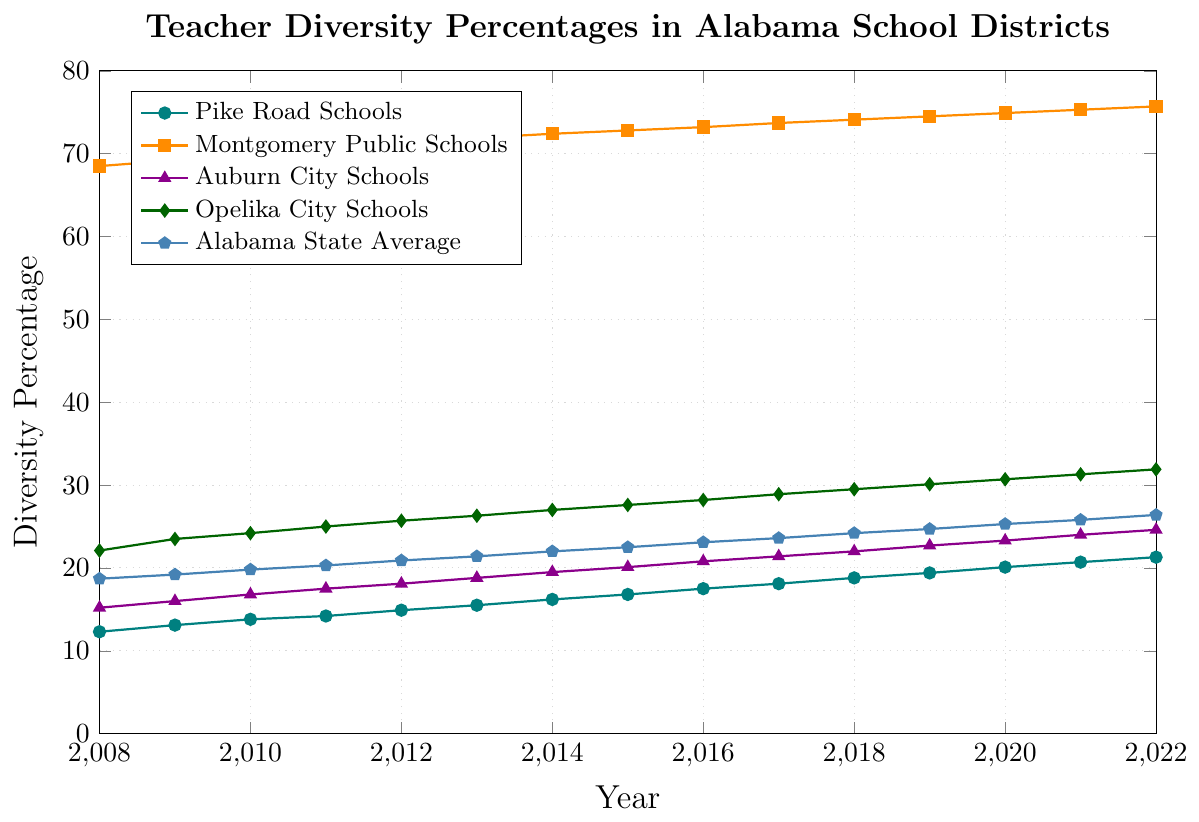What is the diversity percentage of teachers in Pike Road Schools in 2022? To find the diversity percentage for Pike Road Schools in 2022, locate the point corresponding to that year in the Pike Road Schools series (marked with circles) on the chart.
Answer: 21.3% What is the difference in teacher diversity between Montgomery Public Schools and Pike Road Schools in 2010? Subtract the diversity percentage of Pike Road Schools (13.8) from that of Montgomery Public Schools (70.1) for the year 2010.
Answer: 56.3% Which school district has the highest teacher diversity percentage in 2021? Look for the highest point among all series for the year 2021. The series for Montgomery Public Schools (square markers) reaches a percentage of 75.3.
Answer: Montgomery Public Schools Between 2015 and 2022, by how much did the teacher diversity percentage increase in Alabama State Average? Subtract the diversity percentage of Alabama State Average in 2015 (22.5) from the percentage in 2022 (26.4).
Answer: 3.9% Is the teacher diversity in Pike Road Schools in 2022 greater than the teacher diversity in Auburn City Schools in 2012? Compare the diversity percentage of Pike Road Schools in 2022 (21.3) with Auburn City Schools in 2012 (18.1).
Answer: Yes Which school district had the smallest increase in teacher diversity percentage from 2008 to 2022? Calculate the difference in diversity percentage from 2008 to 2022 for each school district and find the smallest value. Pike Road Schools: 21.3-12.3=9.0, Montgomery: 75.7-68.5=7.2, Auburn: 24.6-15.2=9.4, Opelika: 31.9-22.1=9.8, Alabama State Average: 26.4-18.7=7.7.
Answer: Montgomery Public Schools In what year did the teacher diversity percentage of Pike Road Schools hit 20%? Identify the year when the Pike Road Schools series first reaches or exceeds 20% on the y-axis.
Answer: 2020 What is the average teacher diversity percentage in Opelika City Schools over the 15 years displayed? Sum all the diversity percentages for Opelika City Schools from 2008 to 2022 and divide by 15. [(22.1 + 23.5 + 24.2 + 25.0 + 25.7 + 26.3 + 27.0 + 27.6 + 28.2 + 28.9 + 29.5 + 30.1 + 30.7 + 31.3 + 31.9) / 15]
Answer: 27.5% Did any school district surpass the 30% teacher diversity mark before 2019? Observe the chart for any series that have points above 30% before the year 2019. Opelika City Schools surpass this mark in 2019 at 30.1%.
Answer: No 